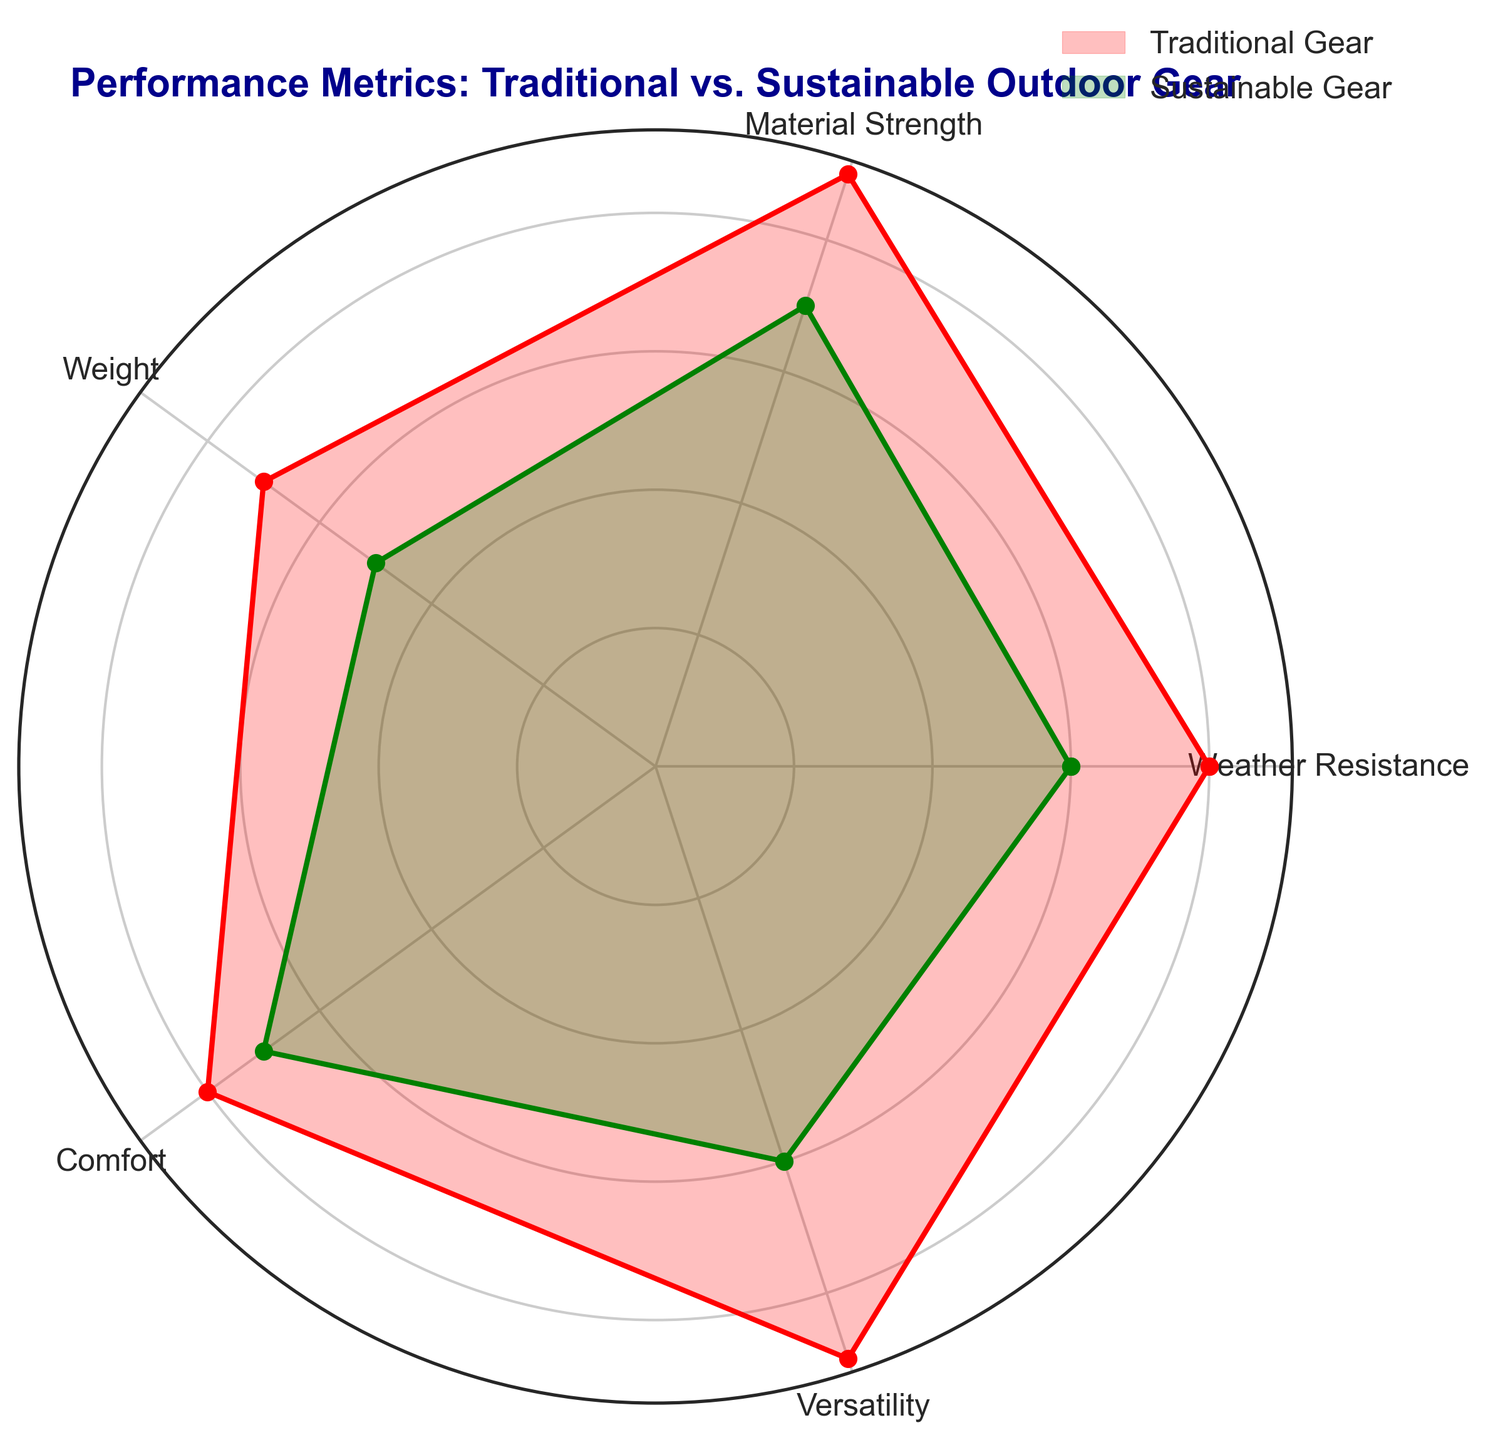What's the difference in Material Strength between Traditional Gear and Sustainable Gear? The Material Strength of Traditional Gear is 9, while Sustainable Gear is 7. The difference is 9 - 7 = 2.
Answer: 2 Which gear performs better in Weather Resistance? The Weather Resistance of Traditional Gear is 8, whereas Sustainable Gear is 6. Traditional Gear performs better as 8 > 6.
Answer: Traditional Gear What's the average score of Comfort for both types of gear? Comfort scores are 8 for Traditional Gear and 7 for Sustainable Gear. The average score is (8 + 7) / 2 = 7.5.
Answer: 7.5 Which metric shows the largest performance difference between the two types of gear? By comparing the differences: Weather Resistance (2), Material Strength (2), Weight (2), Comfort (1), Versatility (3), the largest difference appears in Versatility with a difference of 3.
Answer: Versatility What is the combined score for Versatility and Comfort for Traditional Gear? Traditional Gear’s Versatility is 9 and Comfort is 8. The combined score is 9 + 8 = 17.
Answer: 17 How many metrics does Sustainable Gear outperform Traditional Gear? By comparing each metric: Weather Resistance (Traditional), Material Strength (Traditional), Weight (Traditional), Comfort (Sustainable), Versatility (Traditional), Sustainable Gear only outperforms in Comfort (1 metric).
Answer: 1 Which gear is generally lighter in weight? Sustainable Gear has a Weight score of 5, compared to 7 for Traditional Gear. Therefore, Sustainable Gear is lighter.
Answer: Sustainable Gear What's the total score of all metrics for Sustainable Gear? Summing up Sustainable Gear’s scores: 6 (Weather Resistance) + 7 (Material Strength) + 5 (Weight) + 7 (Comfort) + 6 (Versatility) = 31.
Answer: 31 In which metrics are Traditional Gear and Sustainable Gear equal? None of the metrics have equal scores between Traditional Gear and Sustainable Gear as all scores differ.
Answer: None If one were to choose gear solely based on the highest individual metric scores, which gear would be chosen more often? Traditional Gear has higher scores in Weather Resistance (8 vs. 6), Material Strength (9 vs. 7), Weight (7 vs. 5), and Versatility (9 vs. 6). Sustainable Gear is higher in Comfort (8 vs. 7). Traditional Gear would be chosen more often (4 out of 5 metrics).
Answer: Traditional Gear 